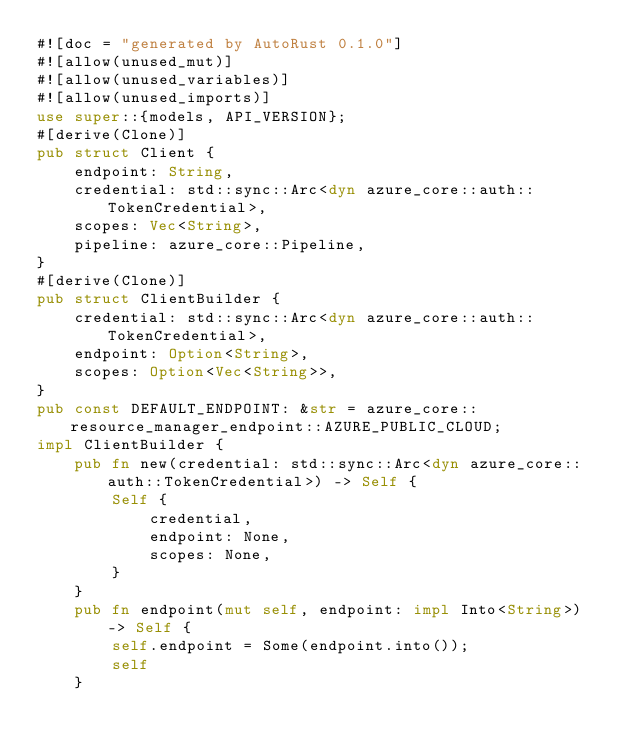Convert code to text. <code><loc_0><loc_0><loc_500><loc_500><_Rust_>#![doc = "generated by AutoRust 0.1.0"]
#![allow(unused_mut)]
#![allow(unused_variables)]
#![allow(unused_imports)]
use super::{models, API_VERSION};
#[derive(Clone)]
pub struct Client {
    endpoint: String,
    credential: std::sync::Arc<dyn azure_core::auth::TokenCredential>,
    scopes: Vec<String>,
    pipeline: azure_core::Pipeline,
}
#[derive(Clone)]
pub struct ClientBuilder {
    credential: std::sync::Arc<dyn azure_core::auth::TokenCredential>,
    endpoint: Option<String>,
    scopes: Option<Vec<String>>,
}
pub const DEFAULT_ENDPOINT: &str = azure_core::resource_manager_endpoint::AZURE_PUBLIC_CLOUD;
impl ClientBuilder {
    pub fn new(credential: std::sync::Arc<dyn azure_core::auth::TokenCredential>) -> Self {
        Self {
            credential,
            endpoint: None,
            scopes: None,
        }
    }
    pub fn endpoint(mut self, endpoint: impl Into<String>) -> Self {
        self.endpoint = Some(endpoint.into());
        self
    }</code> 